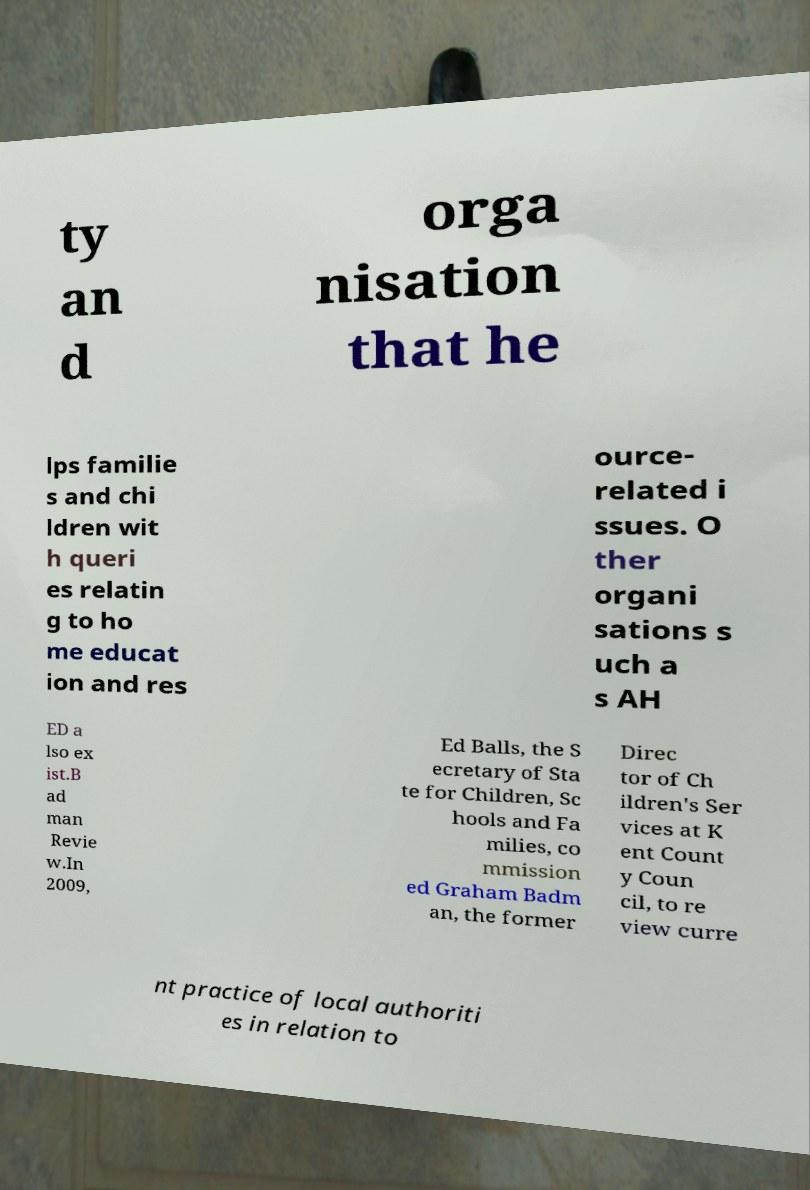Could you assist in decoding the text presented in this image and type it out clearly? ty an d orga nisation that he lps familie s and chi ldren wit h queri es relatin g to ho me educat ion and res ource- related i ssues. O ther organi sations s uch a s AH ED a lso ex ist.B ad man Revie w.In 2009, Ed Balls, the S ecretary of Sta te for Children, Sc hools and Fa milies, co mmission ed Graham Badm an, the former Direc tor of Ch ildren's Ser vices at K ent Count y Coun cil, to re view curre nt practice of local authoriti es in relation to 